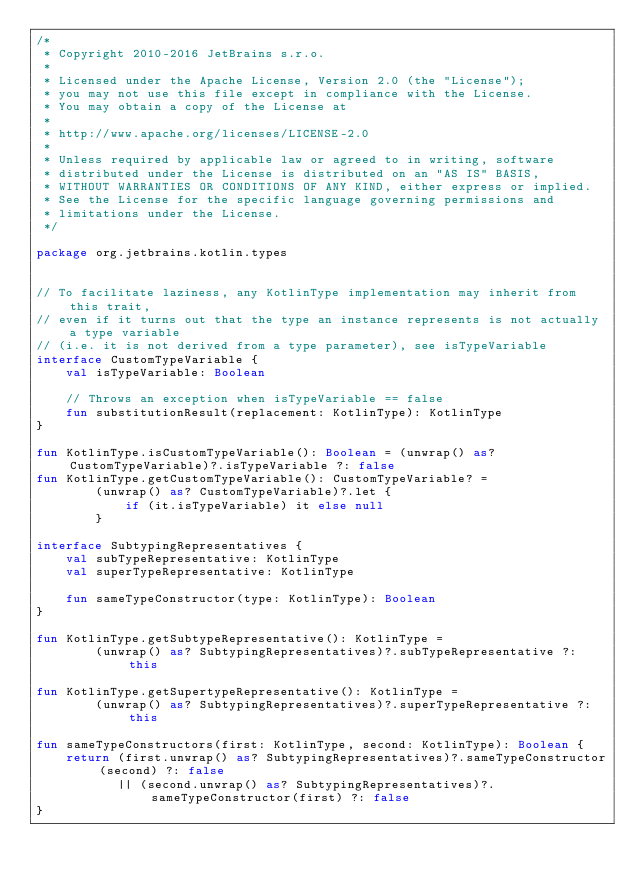Convert code to text. <code><loc_0><loc_0><loc_500><loc_500><_Kotlin_>/*
 * Copyright 2010-2016 JetBrains s.r.o.
 *
 * Licensed under the Apache License, Version 2.0 (the "License");
 * you may not use this file except in compliance with the License.
 * You may obtain a copy of the License at
 *
 * http://www.apache.org/licenses/LICENSE-2.0
 *
 * Unless required by applicable law or agreed to in writing, software
 * distributed under the License is distributed on an "AS IS" BASIS,
 * WITHOUT WARRANTIES OR CONDITIONS OF ANY KIND, either express or implied.
 * See the License for the specific language governing permissions and
 * limitations under the License.
 */

package org.jetbrains.kotlin.types


// To facilitate laziness, any KotlinType implementation may inherit from this trait,
// even if it turns out that the type an instance represents is not actually a type variable
// (i.e. it is not derived from a type parameter), see isTypeVariable
interface CustomTypeVariable {
    val isTypeVariable: Boolean

    // Throws an exception when isTypeVariable == false
    fun substitutionResult(replacement: KotlinType): KotlinType
}

fun KotlinType.isCustomTypeVariable(): Boolean = (unwrap() as? CustomTypeVariable)?.isTypeVariable ?: false
fun KotlinType.getCustomTypeVariable(): CustomTypeVariable? =
        (unwrap() as? CustomTypeVariable)?.let {
            if (it.isTypeVariable) it else null
        }

interface SubtypingRepresentatives {
    val subTypeRepresentative: KotlinType
    val superTypeRepresentative: KotlinType

    fun sameTypeConstructor(type: KotlinType): Boolean
}

fun KotlinType.getSubtypeRepresentative(): KotlinType =
        (unwrap() as? SubtypingRepresentatives)?.subTypeRepresentative ?: this

fun KotlinType.getSupertypeRepresentative(): KotlinType =
        (unwrap() as? SubtypingRepresentatives)?.superTypeRepresentative ?: this

fun sameTypeConstructors(first: KotlinType, second: KotlinType): Boolean {
    return (first.unwrap() as? SubtypingRepresentatives)?.sameTypeConstructor(second) ?: false
           || (second.unwrap() as? SubtypingRepresentatives)?.sameTypeConstructor(first) ?: false
}

</code> 